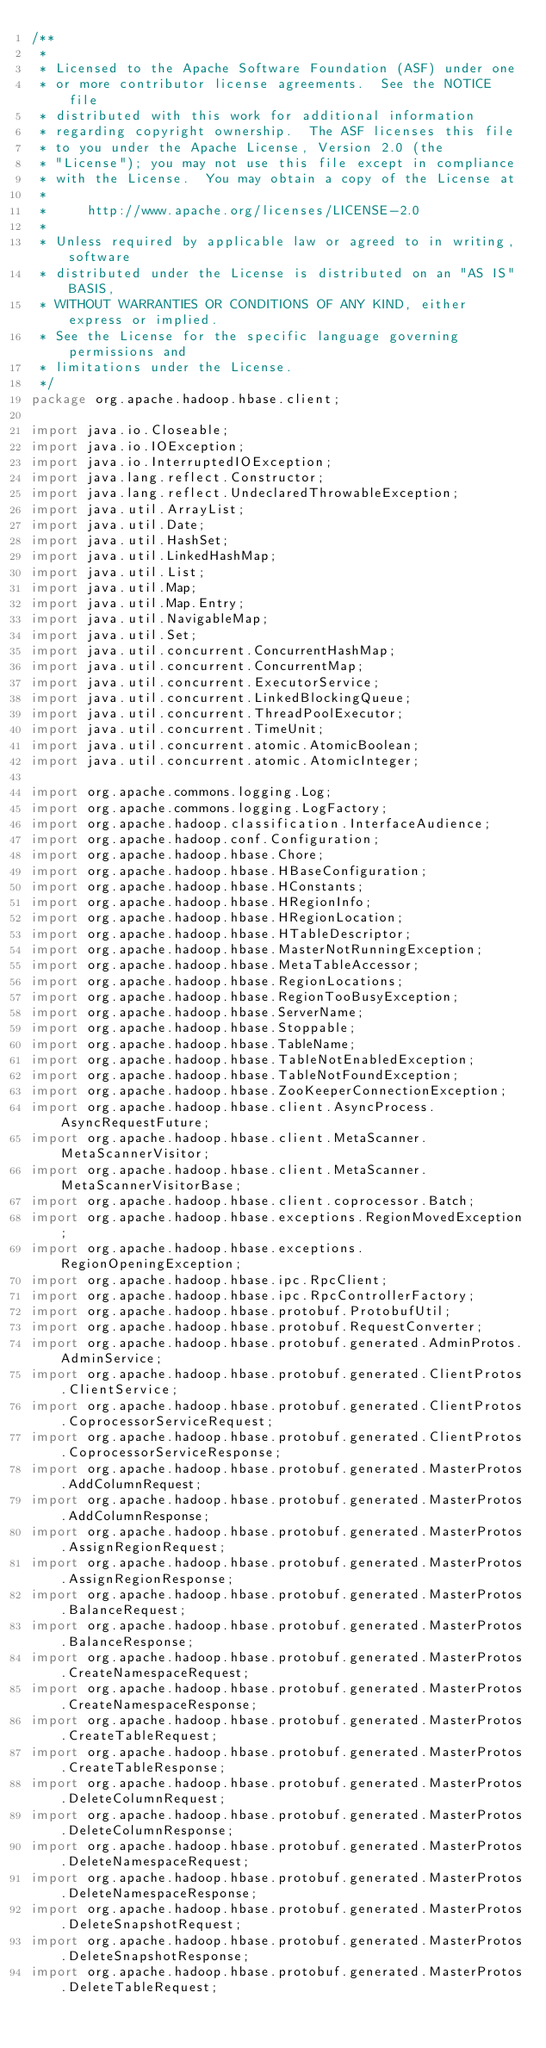Convert code to text. <code><loc_0><loc_0><loc_500><loc_500><_Java_>/**
 *
 * Licensed to the Apache Software Foundation (ASF) under one
 * or more contributor license agreements.  See the NOTICE file
 * distributed with this work for additional information
 * regarding copyright ownership.  The ASF licenses this file
 * to you under the Apache License, Version 2.0 (the
 * "License"); you may not use this file except in compliance
 * with the License.  You may obtain a copy of the License at
 *
 *     http://www.apache.org/licenses/LICENSE-2.0
 *
 * Unless required by applicable law or agreed to in writing, software
 * distributed under the License is distributed on an "AS IS" BASIS,
 * WITHOUT WARRANTIES OR CONDITIONS OF ANY KIND, either express or implied.
 * See the License for the specific language governing permissions and
 * limitations under the License.
 */
package org.apache.hadoop.hbase.client;

import java.io.Closeable;
import java.io.IOException;
import java.io.InterruptedIOException;
import java.lang.reflect.Constructor;
import java.lang.reflect.UndeclaredThrowableException;
import java.util.ArrayList;
import java.util.Date;
import java.util.HashSet;
import java.util.LinkedHashMap;
import java.util.List;
import java.util.Map;
import java.util.Map.Entry;
import java.util.NavigableMap;
import java.util.Set;
import java.util.concurrent.ConcurrentHashMap;
import java.util.concurrent.ConcurrentMap;
import java.util.concurrent.ExecutorService;
import java.util.concurrent.LinkedBlockingQueue;
import java.util.concurrent.ThreadPoolExecutor;
import java.util.concurrent.TimeUnit;
import java.util.concurrent.atomic.AtomicBoolean;
import java.util.concurrent.atomic.AtomicInteger;

import org.apache.commons.logging.Log;
import org.apache.commons.logging.LogFactory;
import org.apache.hadoop.classification.InterfaceAudience;
import org.apache.hadoop.conf.Configuration;
import org.apache.hadoop.hbase.Chore;
import org.apache.hadoop.hbase.HBaseConfiguration;
import org.apache.hadoop.hbase.HConstants;
import org.apache.hadoop.hbase.HRegionInfo;
import org.apache.hadoop.hbase.HRegionLocation;
import org.apache.hadoop.hbase.HTableDescriptor;
import org.apache.hadoop.hbase.MasterNotRunningException;
import org.apache.hadoop.hbase.MetaTableAccessor;
import org.apache.hadoop.hbase.RegionLocations;
import org.apache.hadoop.hbase.RegionTooBusyException;
import org.apache.hadoop.hbase.ServerName;
import org.apache.hadoop.hbase.Stoppable;
import org.apache.hadoop.hbase.TableName;
import org.apache.hadoop.hbase.TableNotEnabledException;
import org.apache.hadoop.hbase.TableNotFoundException;
import org.apache.hadoop.hbase.ZooKeeperConnectionException;
import org.apache.hadoop.hbase.client.AsyncProcess.AsyncRequestFuture;
import org.apache.hadoop.hbase.client.MetaScanner.MetaScannerVisitor;
import org.apache.hadoop.hbase.client.MetaScanner.MetaScannerVisitorBase;
import org.apache.hadoop.hbase.client.coprocessor.Batch;
import org.apache.hadoop.hbase.exceptions.RegionMovedException;
import org.apache.hadoop.hbase.exceptions.RegionOpeningException;
import org.apache.hadoop.hbase.ipc.RpcClient;
import org.apache.hadoop.hbase.ipc.RpcControllerFactory;
import org.apache.hadoop.hbase.protobuf.ProtobufUtil;
import org.apache.hadoop.hbase.protobuf.RequestConverter;
import org.apache.hadoop.hbase.protobuf.generated.AdminProtos.AdminService;
import org.apache.hadoop.hbase.protobuf.generated.ClientProtos.ClientService;
import org.apache.hadoop.hbase.protobuf.generated.ClientProtos.CoprocessorServiceRequest;
import org.apache.hadoop.hbase.protobuf.generated.ClientProtos.CoprocessorServiceResponse;
import org.apache.hadoop.hbase.protobuf.generated.MasterProtos.AddColumnRequest;
import org.apache.hadoop.hbase.protobuf.generated.MasterProtos.AddColumnResponse;
import org.apache.hadoop.hbase.protobuf.generated.MasterProtos.AssignRegionRequest;
import org.apache.hadoop.hbase.protobuf.generated.MasterProtos.AssignRegionResponse;
import org.apache.hadoop.hbase.protobuf.generated.MasterProtos.BalanceRequest;
import org.apache.hadoop.hbase.protobuf.generated.MasterProtos.BalanceResponse;
import org.apache.hadoop.hbase.protobuf.generated.MasterProtos.CreateNamespaceRequest;
import org.apache.hadoop.hbase.protobuf.generated.MasterProtos.CreateNamespaceResponse;
import org.apache.hadoop.hbase.protobuf.generated.MasterProtos.CreateTableRequest;
import org.apache.hadoop.hbase.protobuf.generated.MasterProtos.CreateTableResponse;
import org.apache.hadoop.hbase.protobuf.generated.MasterProtos.DeleteColumnRequest;
import org.apache.hadoop.hbase.protobuf.generated.MasterProtos.DeleteColumnResponse;
import org.apache.hadoop.hbase.protobuf.generated.MasterProtos.DeleteNamespaceRequest;
import org.apache.hadoop.hbase.protobuf.generated.MasterProtos.DeleteNamespaceResponse;
import org.apache.hadoop.hbase.protobuf.generated.MasterProtos.DeleteSnapshotRequest;
import org.apache.hadoop.hbase.protobuf.generated.MasterProtos.DeleteSnapshotResponse;
import org.apache.hadoop.hbase.protobuf.generated.MasterProtos.DeleteTableRequest;</code> 